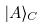<formula> <loc_0><loc_0><loc_500><loc_500>| A \rangle _ { C }</formula> 